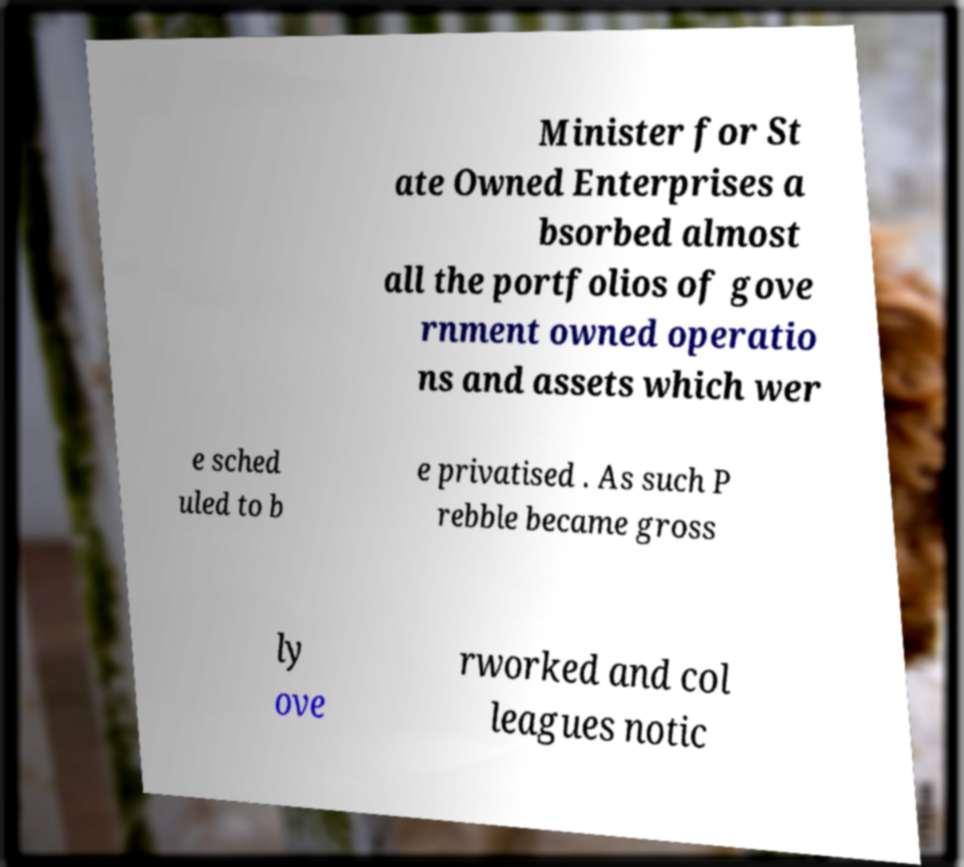Could you extract and type out the text from this image? Minister for St ate Owned Enterprises a bsorbed almost all the portfolios of gove rnment owned operatio ns and assets which wer e sched uled to b e privatised . As such P rebble became gross ly ove rworked and col leagues notic 